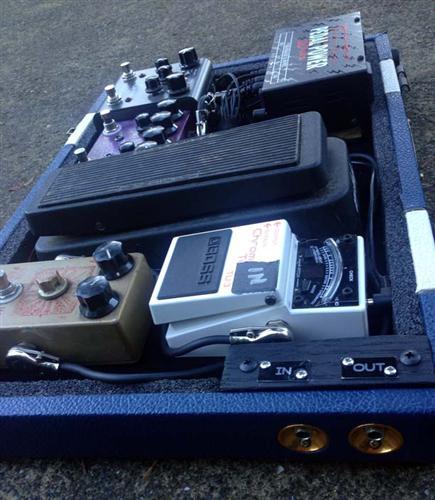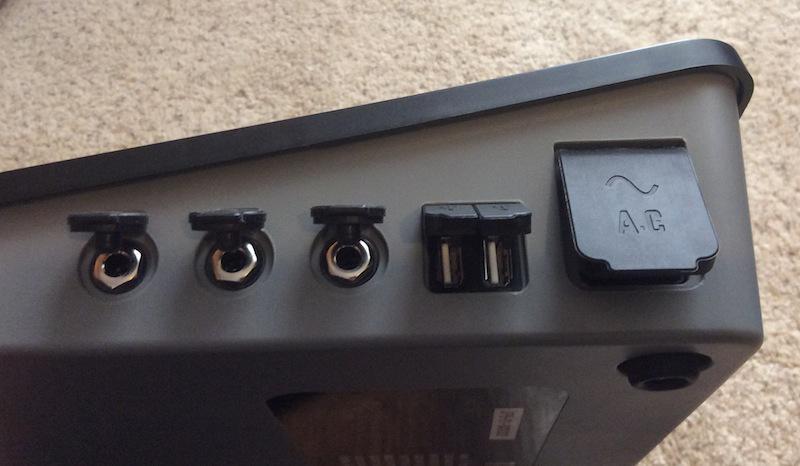The first image is the image on the left, the second image is the image on the right. Analyze the images presented: Is the assertion "Both items are sitting on wood planks." valid? Answer yes or no. No. The first image is the image on the left, the second image is the image on the right. For the images shown, is this caption "The left and right image contains the same number of orange rectangle blocks with three white dots." true? Answer yes or no. No. 